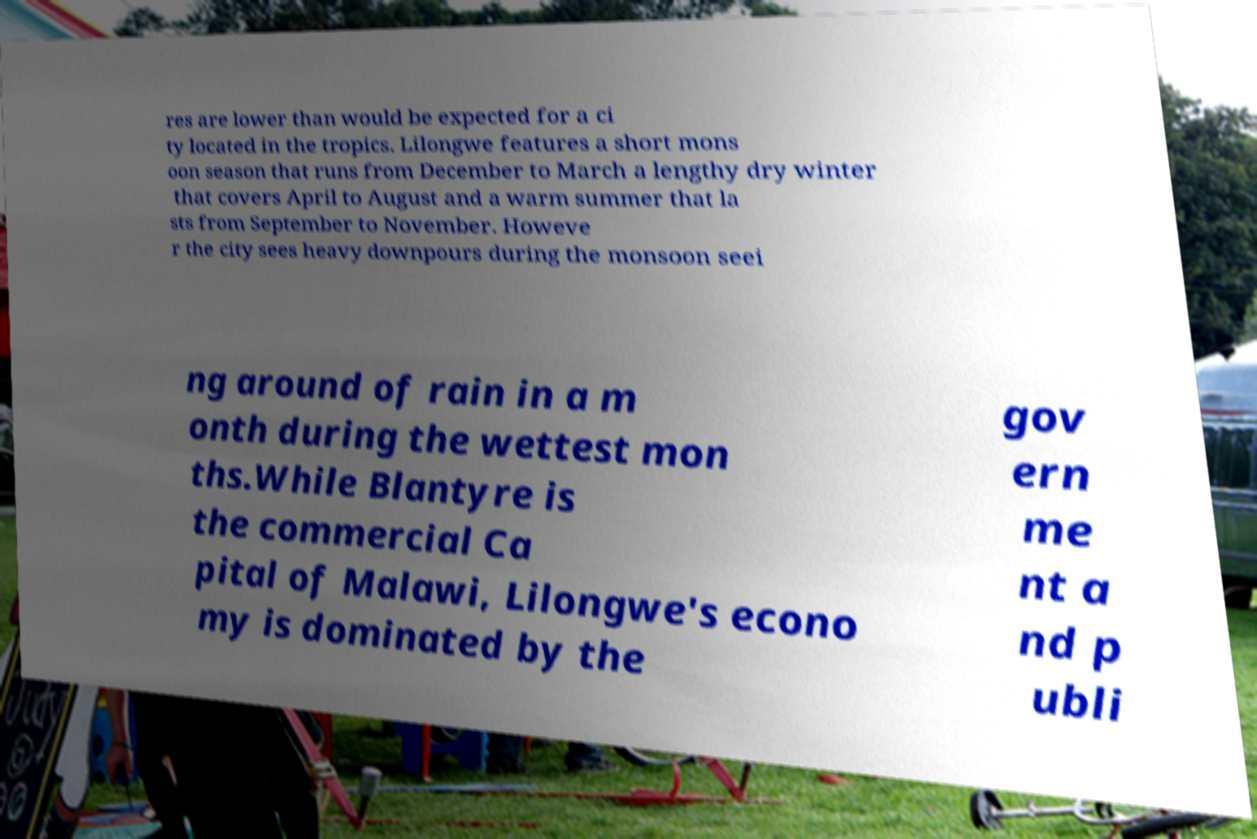Can you accurately transcribe the text from the provided image for me? res are lower than would be expected for a ci ty located in the tropics. Lilongwe features a short mons oon season that runs from December to March a lengthy dry winter that covers April to August and a warm summer that la sts from September to November. Howeve r the city sees heavy downpours during the monsoon seei ng around of rain in a m onth during the wettest mon ths.While Blantyre is the commercial Ca pital of Malawi, Lilongwe's econo my is dominated by the gov ern me nt a nd p ubli 